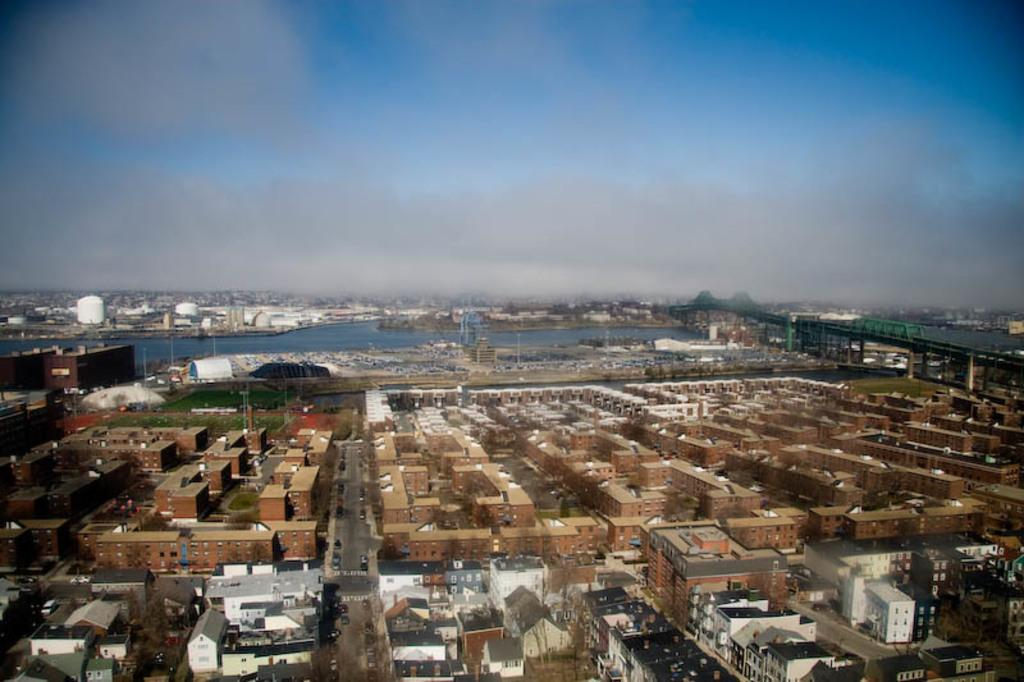What type of structures are located at the bottom of the image? There are buildings at the bottom of the image. What part of the natural environment is visible in the image? The sky is visible at the top of the image. What type of attraction can be seen in the image? There is no specific attraction mentioned or visible in the image; it only features buildings and the sky. 